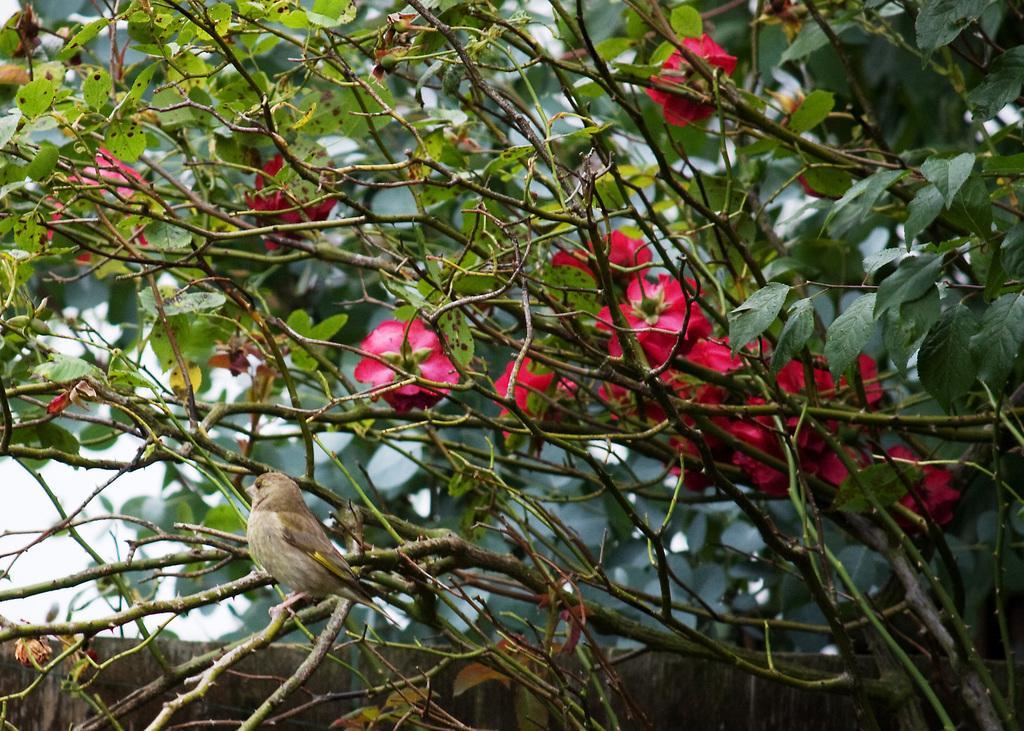Can you describe this image briefly? As we can see in the image there are trees and red color flowers. There is a bird, wall and at the top there is sky. 